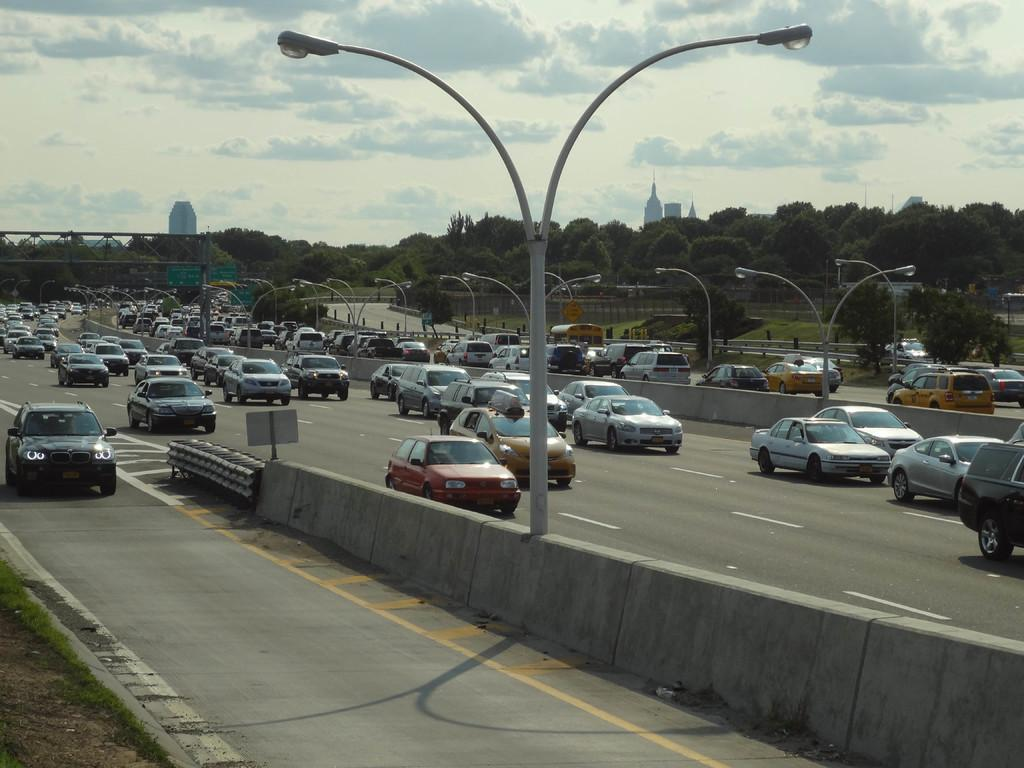What is the main object in the center of the image? There is a streetlight in the center of the image. What is the primary feature of the image? There is a road in the image. How many cars can be seen on the road? There are many cars on the road. What can be seen in the background of the image? There are trees and buildings in the background of the image. What is the taste of the streetlight in the image? Streetlights do not have a taste, as they are not edible objects. 